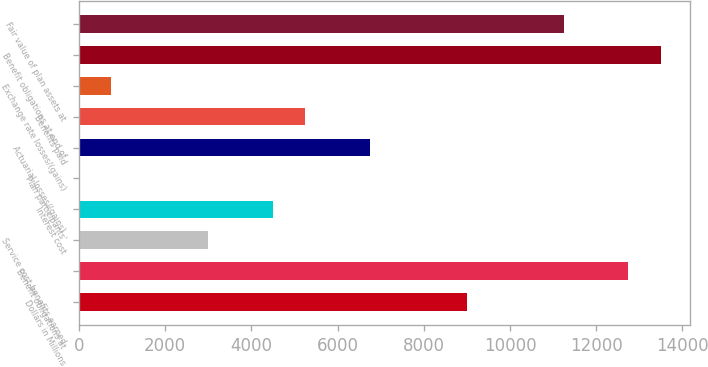<chart> <loc_0><loc_0><loc_500><loc_500><bar_chart><fcel>Dollars in Millions<fcel>Benefit obligations at<fcel>Service cost-benefits earned<fcel>Interest cost<fcel>Plan participants'<fcel>Actuarial losses/(gains)<fcel>Benefits paid<fcel>Exchange rate losses/(gains)<fcel>Benefit obligations at end of<fcel>Fair value of plan assets at<nl><fcel>8998.2<fcel>12746.2<fcel>3001.4<fcel>4500.6<fcel>3<fcel>6749.4<fcel>5250.2<fcel>752.6<fcel>13495.8<fcel>11247<nl></chart> 